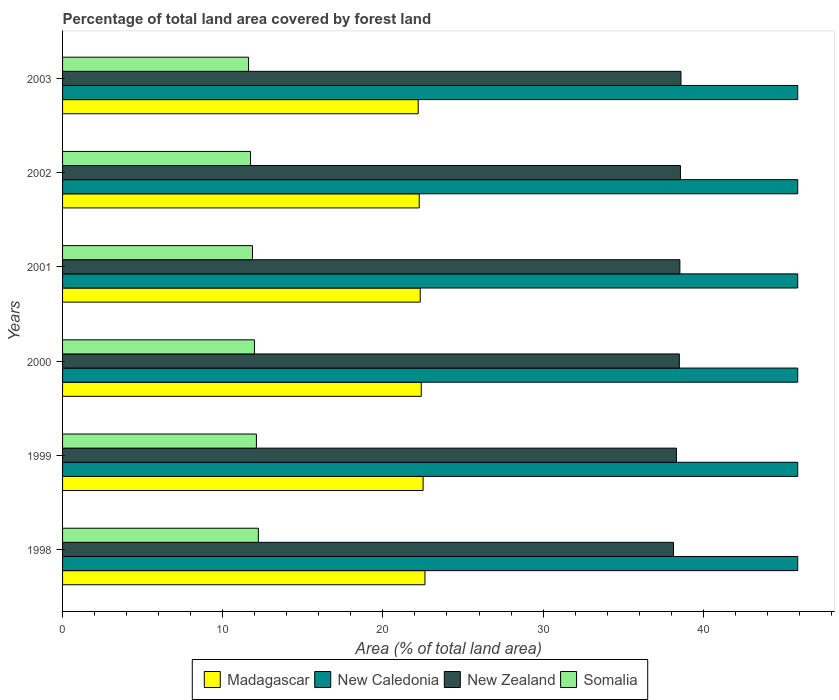How many different coloured bars are there?
Provide a succinct answer. 4. How many groups of bars are there?
Your response must be concise. 6. Are the number of bars on each tick of the Y-axis equal?
Ensure brevity in your answer.  Yes. How many bars are there on the 5th tick from the bottom?
Keep it short and to the point. 4. What is the label of the 5th group of bars from the top?
Provide a succinct answer. 1999. What is the percentage of forest land in Madagascar in 2003?
Keep it short and to the point. 22.2. Across all years, what is the maximum percentage of forest land in New Zealand?
Offer a very short reply. 38.61. Across all years, what is the minimum percentage of forest land in New Caledonia?
Offer a very short reply. 45.9. In which year was the percentage of forest land in Madagascar minimum?
Give a very brief answer. 2003. What is the total percentage of forest land in New Zealand in the graph?
Your answer should be very brief. 230.69. What is the difference between the percentage of forest land in Somalia in 2000 and that in 2001?
Your response must be concise. 0.12. What is the difference between the percentage of forest land in New Caledonia in 2000 and the percentage of forest land in Somalia in 2002?
Give a very brief answer. 34.16. What is the average percentage of forest land in Madagascar per year?
Your answer should be compact. 22.39. In the year 2001, what is the difference between the percentage of forest land in New Zealand and percentage of forest land in Madagascar?
Your response must be concise. 16.21. In how many years, is the percentage of forest land in Madagascar greater than 40 %?
Offer a terse response. 0. What is the ratio of the percentage of forest land in New Zealand in 1999 to that in 2000?
Your response must be concise. 1. What is the difference between the highest and the second highest percentage of forest land in New Zealand?
Offer a terse response. 0.03. What is the difference between the highest and the lowest percentage of forest land in New Zealand?
Provide a succinct answer. 0.47. Is it the case that in every year, the sum of the percentage of forest land in Madagascar and percentage of forest land in New Caledonia is greater than the sum of percentage of forest land in New Zealand and percentage of forest land in Somalia?
Ensure brevity in your answer.  Yes. What does the 3rd bar from the top in 2003 represents?
Ensure brevity in your answer.  New Caledonia. What does the 4th bar from the bottom in 1999 represents?
Offer a terse response. Somalia. How many years are there in the graph?
Make the answer very short. 6. Are the values on the major ticks of X-axis written in scientific E-notation?
Offer a very short reply. No. Does the graph contain any zero values?
Ensure brevity in your answer.  No. Where does the legend appear in the graph?
Ensure brevity in your answer.  Bottom center. How are the legend labels stacked?
Your answer should be very brief. Horizontal. What is the title of the graph?
Provide a succinct answer. Percentage of total land area covered by forest land. Does "Ethiopia" appear as one of the legend labels in the graph?
Provide a succinct answer. No. What is the label or title of the X-axis?
Your answer should be compact. Area (% of total land area). What is the label or title of the Y-axis?
Give a very brief answer. Years. What is the Area (% of total land area) in Madagascar in 1998?
Your response must be concise. 22.62. What is the Area (% of total land area) of New Caledonia in 1998?
Provide a succinct answer. 45.9. What is the Area (% of total land area) of New Zealand in 1998?
Make the answer very short. 38.14. What is the Area (% of total land area) of Somalia in 1998?
Provide a succinct answer. 12.22. What is the Area (% of total land area) of Madagascar in 1999?
Offer a very short reply. 22.51. What is the Area (% of total land area) of New Caledonia in 1999?
Make the answer very short. 45.9. What is the Area (% of total land area) of New Zealand in 1999?
Offer a very short reply. 38.32. What is the Area (% of total land area) of Somalia in 1999?
Offer a very short reply. 12.1. What is the Area (% of total land area) of Madagascar in 2000?
Provide a short and direct response. 22.39. What is the Area (% of total land area) in New Caledonia in 2000?
Give a very brief answer. 45.9. What is the Area (% of total land area) of New Zealand in 2000?
Your answer should be compact. 38.51. What is the Area (% of total land area) of Somalia in 2000?
Provide a short and direct response. 11.98. What is the Area (% of total land area) in Madagascar in 2001?
Provide a succinct answer. 22.33. What is the Area (% of total land area) in New Caledonia in 2001?
Keep it short and to the point. 45.9. What is the Area (% of total land area) of New Zealand in 2001?
Make the answer very short. 38.54. What is the Area (% of total land area) in Somalia in 2001?
Your answer should be compact. 11.86. What is the Area (% of total land area) in Madagascar in 2002?
Ensure brevity in your answer.  22.27. What is the Area (% of total land area) in New Caledonia in 2002?
Offer a terse response. 45.9. What is the Area (% of total land area) of New Zealand in 2002?
Your answer should be compact. 38.57. What is the Area (% of total land area) of Somalia in 2002?
Make the answer very short. 11.73. What is the Area (% of total land area) of Madagascar in 2003?
Your answer should be very brief. 22.2. What is the Area (% of total land area) in New Caledonia in 2003?
Keep it short and to the point. 45.9. What is the Area (% of total land area) of New Zealand in 2003?
Your response must be concise. 38.61. What is the Area (% of total land area) of Somalia in 2003?
Keep it short and to the point. 11.61. Across all years, what is the maximum Area (% of total land area) in Madagascar?
Provide a succinct answer. 22.62. Across all years, what is the maximum Area (% of total land area) in New Caledonia?
Your answer should be very brief. 45.9. Across all years, what is the maximum Area (% of total land area) of New Zealand?
Your answer should be compact. 38.61. Across all years, what is the maximum Area (% of total land area) in Somalia?
Give a very brief answer. 12.22. Across all years, what is the minimum Area (% of total land area) of Madagascar?
Offer a terse response. 22.2. Across all years, what is the minimum Area (% of total land area) of New Caledonia?
Provide a succinct answer. 45.9. Across all years, what is the minimum Area (% of total land area) of New Zealand?
Give a very brief answer. 38.14. Across all years, what is the minimum Area (% of total land area) in Somalia?
Your answer should be compact. 11.61. What is the total Area (% of total land area) in Madagascar in the graph?
Ensure brevity in your answer.  134.33. What is the total Area (% of total land area) of New Caledonia in the graph?
Provide a succinct answer. 275.38. What is the total Area (% of total land area) of New Zealand in the graph?
Make the answer very short. 230.69. What is the total Area (% of total land area) of Somalia in the graph?
Make the answer very short. 71.51. What is the difference between the Area (% of total land area) of Madagascar in 1998 and that in 1999?
Give a very brief answer. 0.12. What is the difference between the Area (% of total land area) of New Zealand in 1998 and that in 1999?
Provide a short and direct response. -0.18. What is the difference between the Area (% of total land area) of Somalia in 1998 and that in 1999?
Ensure brevity in your answer.  0.12. What is the difference between the Area (% of total land area) of Madagascar in 1998 and that in 2000?
Your answer should be compact. 0.23. What is the difference between the Area (% of total land area) in New Zealand in 1998 and that in 2000?
Provide a short and direct response. -0.37. What is the difference between the Area (% of total land area) in Somalia in 1998 and that in 2000?
Make the answer very short. 0.24. What is the difference between the Area (% of total land area) of Madagascar in 1998 and that in 2001?
Provide a succinct answer. 0.29. What is the difference between the Area (% of total land area) in New Zealand in 1998 and that in 2001?
Your answer should be compact. -0.4. What is the difference between the Area (% of total land area) of Somalia in 1998 and that in 2001?
Offer a very short reply. 0.37. What is the difference between the Area (% of total land area) in Madagascar in 1998 and that in 2002?
Offer a very short reply. 0.36. What is the difference between the Area (% of total land area) in New Zealand in 1998 and that in 2002?
Provide a succinct answer. -0.43. What is the difference between the Area (% of total land area) of Somalia in 1998 and that in 2002?
Offer a very short reply. 0.49. What is the difference between the Area (% of total land area) in Madagascar in 1998 and that in 2003?
Your answer should be compact. 0.42. What is the difference between the Area (% of total land area) of New Zealand in 1998 and that in 2003?
Keep it short and to the point. -0.47. What is the difference between the Area (% of total land area) in Somalia in 1998 and that in 2003?
Provide a succinct answer. 0.61. What is the difference between the Area (% of total land area) in Madagascar in 1999 and that in 2000?
Provide a succinct answer. 0.12. What is the difference between the Area (% of total land area) in New Caledonia in 1999 and that in 2000?
Provide a short and direct response. 0. What is the difference between the Area (% of total land area) of New Zealand in 1999 and that in 2000?
Offer a terse response. -0.18. What is the difference between the Area (% of total land area) of Somalia in 1999 and that in 2000?
Keep it short and to the point. 0.12. What is the difference between the Area (% of total land area) of Madagascar in 1999 and that in 2001?
Ensure brevity in your answer.  0.18. What is the difference between the Area (% of total land area) of New Caledonia in 1999 and that in 2001?
Keep it short and to the point. 0. What is the difference between the Area (% of total land area) in New Zealand in 1999 and that in 2001?
Keep it short and to the point. -0.22. What is the difference between the Area (% of total land area) in Somalia in 1999 and that in 2001?
Give a very brief answer. 0.24. What is the difference between the Area (% of total land area) in Madagascar in 1999 and that in 2002?
Offer a very short reply. 0.24. What is the difference between the Area (% of total land area) in New Caledonia in 1999 and that in 2002?
Offer a very short reply. 0. What is the difference between the Area (% of total land area) in New Zealand in 1999 and that in 2002?
Offer a very short reply. -0.25. What is the difference between the Area (% of total land area) in Somalia in 1999 and that in 2002?
Provide a short and direct response. 0.37. What is the difference between the Area (% of total land area) in Madagascar in 1999 and that in 2003?
Your response must be concise. 0.31. What is the difference between the Area (% of total land area) of New Caledonia in 1999 and that in 2003?
Provide a succinct answer. 0. What is the difference between the Area (% of total land area) of New Zealand in 1999 and that in 2003?
Offer a very short reply. -0.28. What is the difference between the Area (% of total land area) of Somalia in 1999 and that in 2003?
Your answer should be very brief. 0.49. What is the difference between the Area (% of total land area) of Madagascar in 2000 and that in 2001?
Offer a very short reply. 0.06. What is the difference between the Area (% of total land area) of New Caledonia in 2000 and that in 2001?
Provide a short and direct response. 0. What is the difference between the Area (% of total land area) in New Zealand in 2000 and that in 2001?
Provide a succinct answer. -0.03. What is the difference between the Area (% of total land area) of Somalia in 2000 and that in 2001?
Ensure brevity in your answer.  0.12. What is the difference between the Area (% of total land area) of Madagascar in 2000 and that in 2002?
Your answer should be compact. 0.13. What is the difference between the Area (% of total land area) in New Caledonia in 2000 and that in 2002?
Provide a short and direct response. 0. What is the difference between the Area (% of total land area) in New Zealand in 2000 and that in 2002?
Your answer should be compact. -0.07. What is the difference between the Area (% of total land area) of Somalia in 2000 and that in 2002?
Ensure brevity in your answer.  0.24. What is the difference between the Area (% of total land area) in Madagascar in 2000 and that in 2003?
Your answer should be very brief. 0.19. What is the difference between the Area (% of total land area) in New Caledonia in 2000 and that in 2003?
Your answer should be very brief. 0. What is the difference between the Area (% of total land area) in New Zealand in 2000 and that in 2003?
Ensure brevity in your answer.  -0.1. What is the difference between the Area (% of total land area) of Somalia in 2000 and that in 2003?
Your answer should be very brief. 0.37. What is the difference between the Area (% of total land area) of Madagascar in 2001 and that in 2002?
Keep it short and to the point. 0.06. What is the difference between the Area (% of total land area) in New Zealand in 2001 and that in 2002?
Your answer should be compact. -0.03. What is the difference between the Area (% of total land area) in Somalia in 2001 and that in 2002?
Provide a short and direct response. 0.12. What is the difference between the Area (% of total land area) of Madagascar in 2001 and that in 2003?
Provide a succinct answer. 0.13. What is the difference between the Area (% of total land area) in New Zealand in 2001 and that in 2003?
Provide a succinct answer. -0.07. What is the difference between the Area (% of total land area) in Somalia in 2001 and that in 2003?
Your answer should be very brief. 0.24. What is the difference between the Area (% of total land area) in Madagascar in 2002 and that in 2003?
Your response must be concise. 0.06. What is the difference between the Area (% of total land area) of New Zealand in 2002 and that in 2003?
Make the answer very short. -0.03. What is the difference between the Area (% of total land area) of Somalia in 2002 and that in 2003?
Your answer should be very brief. 0.12. What is the difference between the Area (% of total land area) of Madagascar in 1998 and the Area (% of total land area) of New Caledonia in 1999?
Offer a very short reply. -23.27. What is the difference between the Area (% of total land area) in Madagascar in 1998 and the Area (% of total land area) in New Zealand in 1999?
Offer a very short reply. -15.7. What is the difference between the Area (% of total land area) of Madagascar in 1998 and the Area (% of total land area) of Somalia in 1999?
Provide a succinct answer. 10.52. What is the difference between the Area (% of total land area) in New Caledonia in 1998 and the Area (% of total land area) in New Zealand in 1999?
Your response must be concise. 7.57. What is the difference between the Area (% of total land area) in New Caledonia in 1998 and the Area (% of total land area) in Somalia in 1999?
Your response must be concise. 33.8. What is the difference between the Area (% of total land area) of New Zealand in 1998 and the Area (% of total land area) of Somalia in 1999?
Provide a short and direct response. 26.04. What is the difference between the Area (% of total land area) of Madagascar in 1998 and the Area (% of total land area) of New Caledonia in 2000?
Offer a terse response. -23.27. What is the difference between the Area (% of total land area) of Madagascar in 1998 and the Area (% of total land area) of New Zealand in 2000?
Offer a terse response. -15.88. What is the difference between the Area (% of total land area) of Madagascar in 1998 and the Area (% of total land area) of Somalia in 2000?
Offer a terse response. 10.64. What is the difference between the Area (% of total land area) of New Caledonia in 1998 and the Area (% of total land area) of New Zealand in 2000?
Your answer should be compact. 7.39. What is the difference between the Area (% of total land area) in New Caledonia in 1998 and the Area (% of total land area) in Somalia in 2000?
Your response must be concise. 33.92. What is the difference between the Area (% of total land area) in New Zealand in 1998 and the Area (% of total land area) in Somalia in 2000?
Provide a short and direct response. 26.16. What is the difference between the Area (% of total land area) of Madagascar in 1998 and the Area (% of total land area) of New Caledonia in 2001?
Offer a terse response. -23.27. What is the difference between the Area (% of total land area) of Madagascar in 1998 and the Area (% of total land area) of New Zealand in 2001?
Your response must be concise. -15.92. What is the difference between the Area (% of total land area) of Madagascar in 1998 and the Area (% of total land area) of Somalia in 2001?
Ensure brevity in your answer.  10.77. What is the difference between the Area (% of total land area) of New Caledonia in 1998 and the Area (% of total land area) of New Zealand in 2001?
Your answer should be compact. 7.36. What is the difference between the Area (% of total land area) of New Caledonia in 1998 and the Area (% of total land area) of Somalia in 2001?
Ensure brevity in your answer.  34.04. What is the difference between the Area (% of total land area) of New Zealand in 1998 and the Area (% of total land area) of Somalia in 2001?
Your answer should be compact. 26.28. What is the difference between the Area (% of total land area) in Madagascar in 1998 and the Area (% of total land area) in New Caledonia in 2002?
Your response must be concise. -23.27. What is the difference between the Area (% of total land area) in Madagascar in 1998 and the Area (% of total land area) in New Zealand in 2002?
Keep it short and to the point. -15.95. What is the difference between the Area (% of total land area) of Madagascar in 1998 and the Area (% of total land area) of Somalia in 2002?
Provide a short and direct response. 10.89. What is the difference between the Area (% of total land area) of New Caledonia in 1998 and the Area (% of total land area) of New Zealand in 2002?
Ensure brevity in your answer.  7.32. What is the difference between the Area (% of total land area) of New Caledonia in 1998 and the Area (% of total land area) of Somalia in 2002?
Keep it short and to the point. 34.16. What is the difference between the Area (% of total land area) in New Zealand in 1998 and the Area (% of total land area) in Somalia in 2002?
Ensure brevity in your answer.  26.41. What is the difference between the Area (% of total land area) in Madagascar in 1998 and the Area (% of total land area) in New Caledonia in 2003?
Provide a short and direct response. -23.27. What is the difference between the Area (% of total land area) of Madagascar in 1998 and the Area (% of total land area) of New Zealand in 2003?
Your answer should be compact. -15.98. What is the difference between the Area (% of total land area) in Madagascar in 1998 and the Area (% of total land area) in Somalia in 2003?
Your answer should be compact. 11.01. What is the difference between the Area (% of total land area) of New Caledonia in 1998 and the Area (% of total land area) of New Zealand in 2003?
Your answer should be very brief. 7.29. What is the difference between the Area (% of total land area) of New Caledonia in 1998 and the Area (% of total land area) of Somalia in 2003?
Give a very brief answer. 34.29. What is the difference between the Area (% of total land area) in New Zealand in 1998 and the Area (% of total land area) in Somalia in 2003?
Your answer should be very brief. 26.53. What is the difference between the Area (% of total land area) of Madagascar in 1999 and the Area (% of total land area) of New Caledonia in 2000?
Your response must be concise. -23.39. What is the difference between the Area (% of total land area) of Madagascar in 1999 and the Area (% of total land area) of New Zealand in 2000?
Make the answer very short. -16. What is the difference between the Area (% of total land area) of Madagascar in 1999 and the Area (% of total land area) of Somalia in 2000?
Give a very brief answer. 10.53. What is the difference between the Area (% of total land area) of New Caledonia in 1999 and the Area (% of total land area) of New Zealand in 2000?
Give a very brief answer. 7.39. What is the difference between the Area (% of total land area) in New Caledonia in 1999 and the Area (% of total land area) in Somalia in 2000?
Provide a short and direct response. 33.92. What is the difference between the Area (% of total land area) of New Zealand in 1999 and the Area (% of total land area) of Somalia in 2000?
Keep it short and to the point. 26.34. What is the difference between the Area (% of total land area) of Madagascar in 1999 and the Area (% of total land area) of New Caledonia in 2001?
Ensure brevity in your answer.  -23.39. What is the difference between the Area (% of total land area) of Madagascar in 1999 and the Area (% of total land area) of New Zealand in 2001?
Keep it short and to the point. -16.03. What is the difference between the Area (% of total land area) of Madagascar in 1999 and the Area (% of total land area) of Somalia in 2001?
Your response must be concise. 10.65. What is the difference between the Area (% of total land area) in New Caledonia in 1999 and the Area (% of total land area) in New Zealand in 2001?
Offer a very short reply. 7.36. What is the difference between the Area (% of total land area) of New Caledonia in 1999 and the Area (% of total land area) of Somalia in 2001?
Provide a succinct answer. 34.04. What is the difference between the Area (% of total land area) of New Zealand in 1999 and the Area (% of total land area) of Somalia in 2001?
Provide a short and direct response. 26.47. What is the difference between the Area (% of total land area) in Madagascar in 1999 and the Area (% of total land area) in New Caledonia in 2002?
Keep it short and to the point. -23.39. What is the difference between the Area (% of total land area) of Madagascar in 1999 and the Area (% of total land area) of New Zealand in 2002?
Your response must be concise. -16.06. What is the difference between the Area (% of total land area) of Madagascar in 1999 and the Area (% of total land area) of Somalia in 2002?
Provide a succinct answer. 10.77. What is the difference between the Area (% of total land area) in New Caledonia in 1999 and the Area (% of total land area) in New Zealand in 2002?
Your answer should be very brief. 7.32. What is the difference between the Area (% of total land area) in New Caledonia in 1999 and the Area (% of total land area) in Somalia in 2002?
Offer a very short reply. 34.16. What is the difference between the Area (% of total land area) in New Zealand in 1999 and the Area (% of total land area) in Somalia in 2002?
Offer a very short reply. 26.59. What is the difference between the Area (% of total land area) of Madagascar in 1999 and the Area (% of total land area) of New Caledonia in 2003?
Offer a terse response. -23.39. What is the difference between the Area (% of total land area) in Madagascar in 1999 and the Area (% of total land area) in New Zealand in 2003?
Provide a succinct answer. -16.1. What is the difference between the Area (% of total land area) in Madagascar in 1999 and the Area (% of total land area) in Somalia in 2003?
Keep it short and to the point. 10.9. What is the difference between the Area (% of total land area) of New Caledonia in 1999 and the Area (% of total land area) of New Zealand in 2003?
Give a very brief answer. 7.29. What is the difference between the Area (% of total land area) in New Caledonia in 1999 and the Area (% of total land area) in Somalia in 2003?
Offer a terse response. 34.29. What is the difference between the Area (% of total land area) of New Zealand in 1999 and the Area (% of total land area) of Somalia in 2003?
Your answer should be compact. 26.71. What is the difference between the Area (% of total land area) of Madagascar in 2000 and the Area (% of total land area) of New Caledonia in 2001?
Make the answer very short. -23.5. What is the difference between the Area (% of total land area) in Madagascar in 2000 and the Area (% of total land area) in New Zealand in 2001?
Give a very brief answer. -16.15. What is the difference between the Area (% of total land area) of Madagascar in 2000 and the Area (% of total land area) of Somalia in 2001?
Give a very brief answer. 10.54. What is the difference between the Area (% of total land area) in New Caledonia in 2000 and the Area (% of total land area) in New Zealand in 2001?
Your response must be concise. 7.36. What is the difference between the Area (% of total land area) of New Caledonia in 2000 and the Area (% of total land area) of Somalia in 2001?
Provide a succinct answer. 34.04. What is the difference between the Area (% of total land area) in New Zealand in 2000 and the Area (% of total land area) in Somalia in 2001?
Your response must be concise. 26.65. What is the difference between the Area (% of total land area) of Madagascar in 2000 and the Area (% of total land area) of New Caledonia in 2002?
Your response must be concise. -23.5. What is the difference between the Area (% of total land area) in Madagascar in 2000 and the Area (% of total land area) in New Zealand in 2002?
Ensure brevity in your answer.  -16.18. What is the difference between the Area (% of total land area) of Madagascar in 2000 and the Area (% of total land area) of Somalia in 2002?
Offer a terse response. 10.66. What is the difference between the Area (% of total land area) in New Caledonia in 2000 and the Area (% of total land area) in New Zealand in 2002?
Ensure brevity in your answer.  7.32. What is the difference between the Area (% of total land area) in New Caledonia in 2000 and the Area (% of total land area) in Somalia in 2002?
Give a very brief answer. 34.16. What is the difference between the Area (% of total land area) in New Zealand in 2000 and the Area (% of total land area) in Somalia in 2002?
Provide a succinct answer. 26.77. What is the difference between the Area (% of total land area) of Madagascar in 2000 and the Area (% of total land area) of New Caledonia in 2003?
Give a very brief answer. -23.5. What is the difference between the Area (% of total land area) of Madagascar in 2000 and the Area (% of total land area) of New Zealand in 2003?
Your answer should be compact. -16.21. What is the difference between the Area (% of total land area) in Madagascar in 2000 and the Area (% of total land area) in Somalia in 2003?
Provide a succinct answer. 10.78. What is the difference between the Area (% of total land area) of New Caledonia in 2000 and the Area (% of total land area) of New Zealand in 2003?
Your response must be concise. 7.29. What is the difference between the Area (% of total land area) in New Caledonia in 2000 and the Area (% of total land area) in Somalia in 2003?
Ensure brevity in your answer.  34.29. What is the difference between the Area (% of total land area) in New Zealand in 2000 and the Area (% of total land area) in Somalia in 2003?
Offer a very short reply. 26.89. What is the difference between the Area (% of total land area) of Madagascar in 2001 and the Area (% of total land area) of New Caledonia in 2002?
Keep it short and to the point. -23.57. What is the difference between the Area (% of total land area) of Madagascar in 2001 and the Area (% of total land area) of New Zealand in 2002?
Keep it short and to the point. -16.24. What is the difference between the Area (% of total land area) in Madagascar in 2001 and the Area (% of total land area) in Somalia in 2002?
Your response must be concise. 10.6. What is the difference between the Area (% of total land area) in New Caledonia in 2001 and the Area (% of total land area) in New Zealand in 2002?
Offer a very short reply. 7.32. What is the difference between the Area (% of total land area) of New Caledonia in 2001 and the Area (% of total land area) of Somalia in 2002?
Give a very brief answer. 34.16. What is the difference between the Area (% of total land area) in New Zealand in 2001 and the Area (% of total land area) in Somalia in 2002?
Keep it short and to the point. 26.81. What is the difference between the Area (% of total land area) in Madagascar in 2001 and the Area (% of total land area) in New Caledonia in 2003?
Ensure brevity in your answer.  -23.57. What is the difference between the Area (% of total land area) of Madagascar in 2001 and the Area (% of total land area) of New Zealand in 2003?
Your response must be concise. -16.28. What is the difference between the Area (% of total land area) of Madagascar in 2001 and the Area (% of total land area) of Somalia in 2003?
Give a very brief answer. 10.72. What is the difference between the Area (% of total land area) in New Caledonia in 2001 and the Area (% of total land area) in New Zealand in 2003?
Offer a very short reply. 7.29. What is the difference between the Area (% of total land area) in New Caledonia in 2001 and the Area (% of total land area) in Somalia in 2003?
Ensure brevity in your answer.  34.29. What is the difference between the Area (% of total land area) of New Zealand in 2001 and the Area (% of total land area) of Somalia in 2003?
Give a very brief answer. 26.93. What is the difference between the Area (% of total land area) in Madagascar in 2002 and the Area (% of total land area) in New Caledonia in 2003?
Your answer should be very brief. -23.63. What is the difference between the Area (% of total land area) of Madagascar in 2002 and the Area (% of total land area) of New Zealand in 2003?
Make the answer very short. -16.34. What is the difference between the Area (% of total land area) in Madagascar in 2002 and the Area (% of total land area) in Somalia in 2003?
Offer a terse response. 10.65. What is the difference between the Area (% of total land area) in New Caledonia in 2002 and the Area (% of total land area) in New Zealand in 2003?
Offer a terse response. 7.29. What is the difference between the Area (% of total land area) in New Caledonia in 2002 and the Area (% of total land area) in Somalia in 2003?
Offer a very short reply. 34.29. What is the difference between the Area (% of total land area) of New Zealand in 2002 and the Area (% of total land area) of Somalia in 2003?
Offer a terse response. 26.96. What is the average Area (% of total land area) in Madagascar per year?
Provide a short and direct response. 22.39. What is the average Area (% of total land area) in New Caledonia per year?
Keep it short and to the point. 45.9. What is the average Area (% of total land area) of New Zealand per year?
Keep it short and to the point. 38.45. What is the average Area (% of total land area) in Somalia per year?
Ensure brevity in your answer.  11.92. In the year 1998, what is the difference between the Area (% of total land area) in Madagascar and Area (% of total land area) in New Caledonia?
Ensure brevity in your answer.  -23.27. In the year 1998, what is the difference between the Area (% of total land area) of Madagascar and Area (% of total land area) of New Zealand?
Keep it short and to the point. -15.52. In the year 1998, what is the difference between the Area (% of total land area) of Madagascar and Area (% of total land area) of Somalia?
Make the answer very short. 10.4. In the year 1998, what is the difference between the Area (% of total land area) in New Caledonia and Area (% of total land area) in New Zealand?
Provide a succinct answer. 7.76. In the year 1998, what is the difference between the Area (% of total land area) in New Caledonia and Area (% of total land area) in Somalia?
Give a very brief answer. 33.67. In the year 1998, what is the difference between the Area (% of total land area) of New Zealand and Area (% of total land area) of Somalia?
Keep it short and to the point. 25.92. In the year 1999, what is the difference between the Area (% of total land area) in Madagascar and Area (% of total land area) in New Caledonia?
Provide a succinct answer. -23.39. In the year 1999, what is the difference between the Area (% of total land area) in Madagascar and Area (% of total land area) in New Zealand?
Keep it short and to the point. -15.81. In the year 1999, what is the difference between the Area (% of total land area) in Madagascar and Area (% of total land area) in Somalia?
Give a very brief answer. 10.41. In the year 1999, what is the difference between the Area (% of total land area) of New Caledonia and Area (% of total land area) of New Zealand?
Provide a short and direct response. 7.57. In the year 1999, what is the difference between the Area (% of total land area) in New Caledonia and Area (% of total land area) in Somalia?
Ensure brevity in your answer.  33.8. In the year 1999, what is the difference between the Area (% of total land area) of New Zealand and Area (% of total land area) of Somalia?
Give a very brief answer. 26.22. In the year 2000, what is the difference between the Area (% of total land area) in Madagascar and Area (% of total land area) in New Caledonia?
Your answer should be compact. -23.5. In the year 2000, what is the difference between the Area (% of total land area) in Madagascar and Area (% of total land area) in New Zealand?
Make the answer very short. -16.11. In the year 2000, what is the difference between the Area (% of total land area) of Madagascar and Area (% of total land area) of Somalia?
Provide a succinct answer. 10.41. In the year 2000, what is the difference between the Area (% of total land area) in New Caledonia and Area (% of total land area) in New Zealand?
Give a very brief answer. 7.39. In the year 2000, what is the difference between the Area (% of total land area) of New Caledonia and Area (% of total land area) of Somalia?
Give a very brief answer. 33.92. In the year 2000, what is the difference between the Area (% of total land area) of New Zealand and Area (% of total land area) of Somalia?
Your answer should be compact. 26.53. In the year 2001, what is the difference between the Area (% of total land area) of Madagascar and Area (% of total land area) of New Caledonia?
Ensure brevity in your answer.  -23.57. In the year 2001, what is the difference between the Area (% of total land area) in Madagascar and Area (% of total land area) in New Zealand?
Give a very brief answer. -16.21. In the year 2001, what is the difference between the Area (% of total land area) in Madagascar and Area (% of total land area) in Somalia?
Keep it short and to the point. 10.47. In the year 2001, what is the difference between the Area (% of total land area) of New Caledonia and Area (% of total land area) of New Zealand?
Ensure brevity in your answer.  7.36. In the year 2001, what is the difference between the Area (% of total land area) of New Caledonia and Area (% of total land area) of Somalia?
Your response must be concise. 34.04. In the year 2001, what is the difference between the Area (% of total land area) of New Zealand and Area (% of total land area) of Somalia?
Give a very brief answer. 26.68. In the year 2002, what is the difference between the Area (% of total land area) of Madagascar and Area (% of total land area) of New Caledonia?
Offer a terse response. -23.63. In the year 2002, what is the difference between the Area (% of total land area) of Madagascar and Area (% of total land area) of New Zealand?
Your answer should be very brief. -16.31. In the year 2002, what is the difference between the Area (% of total land area) in Madagascar and Area (% of total land area) in Somalia?
Offer a very short reply. 10.53. In the year 2002, what is the difference between the Area (% of total land area) of New Caledonia and Area (% of total land area) of New Zealand?
Provide a short and direct response. 7.32. In the year 2002, what is the difference between the Area (% of total land area) in New Caledonia and Area (% of total land area) in Somalia?
Your answer should be very brief. 34.16. In the year 2002, what is the difference between the Area (% of total land area) in New Zealand and Area (% of total land area) in Somalia?
Make the answer very short. 26.84. In the year 2003, what is the difference between the Area (% of total land area) of Madagascar and Area (% of total land area) of New Caledonia?
Your answer should be compact. -23.69. In the year 2003, what is the difference between the Area (% of total land area) of Madagascar and Area (% of total land area) of New Zealand?
Make the answer very short. -16.4. In the year 2003, what is the difference between the Area (% of total land area) of Madagascar and Area (% of total land area) of Somalia?
Your answer should be compact. 10.59. In the year 2003, what is the difference between the Area (% of total land area) in New Caledonia and Area (% of total land area) in New Zealand?
Your answer should be compact. 7.29. In the year 2003, what is the difference between the Area (% of total land area) in New Caledonia and Area (% of total land area) in Somalia?
Your answer should be compact. 34.29. In the year 2003, what is the difference between the Area (% of total land area) of New Zealand and Area (% of total land area) of Somalia?
Your answer should be compact. 26.99. What is the ratio of the Area (% of total land area) of New Zealand in 1998 to that in 1999?
Provide a succinct answer. 1. What is the ratio of the Area (% of total land area) of Somalia in 1998 to that in 1999?
Provide a short and direct response. 1.01. What is the ratio of the Area (% of total land area) in Madagascar in 1998 to that in 2000?
Provide a short and direct response. 1.01. What is the ratio of the Area (% of total land area) of New Caledonia in 1998 to that in 2000?
Your answer should be very brief. 1. What is the ratio of the Area (% of total land area) in Somalia in 1998 to that in 2000?
Keep it short and to the point. 1.02. What is the ratio of the Area (% of total land area) in Madagascar in 1998 to that in 2001?
Your response must be concise. 1.01. What is the ratio of the Area (% of total land area) in New Zealand in 1998 to that in 2001?
Your response must be concise. 0.99. What is the ratio of the Area (% of total land area) of Somalia in 1998 to that in 2001?
Keep it short and to the point. 1.03. What is the ratio of the Area (% of total land area) in New Caledonia in 1998 to that in 2002?
Offer a terse response. 1. What is the ratio of the Area (% of total land area) of Somalia in 1998 to that in 2002?
Offer a terse response. 1.04. What is the ratio of the Area (% of total land area) in New Caledonia in 1998 to that in 2003?
Ensure brevity in your answer.  1. What is the ratio of the Area (% of total land area) of New Zealand in 1998 to that in 2003?
Your answer should be compact. 0.99. What is the ratio of the Area (% of total land area) in Somalia in 1998 to that in 2003?
Provide a short and direct response. 1.05. What is the ratio of the Area (% of total land area) in Madagascar in 1999 to that in 2000?
Make the answer very short. 1.01. What is the ratio of the Area (% of total land area) in Somalia in 1999 to that in 2000?
Offer a terse response. 1.01. What is the ratio of the Area (% of total land area) of Madagascar in 1999 to that in 2001?
Keep it short and to the point. 1.01. What is the ratio of the Area (% of total land area) of New Caledonia in 1999 to that in 2001?
Make the answer very short. 1. What is the ratio of the Area (% of total land area) in Somalia in 1999 to that in 2001?
Offer a terse response. 1.02. What is the ratio of the Area (% of total land area) in Madagascar in 1999 to that in 2002?
Keep it short and to the point. 1.01. What is the ratio of the Area (% of total land area) in New Caledonia in 1999 to that in 2002?
Your answer should be compact. 1. What is the ratio of the Area (% of total land area) in Somalia in 1999 to that in 2002?
Ensure brevity in your answer.  1.03. What is the ratio of the Area (% of total land area) of Madagascar in 1999 to that in 2003?
Offer a very short reply. 1.01. What is the ratio of the Area (% of total land area) in Somalia in 1999 to that in 2003?
Your answer should be compact. 1.04. What is the ratio of the Area (% of total land area) of Madagascar in 2000 to that in 2001?
Keep it short and to the point. 1. What is the ratio of the Area (% of total land area) of Somalia in 2000 to that in 2001?
Give a very brief answer. 1.01. What is the ratio of the Area (% of total land area) of New Caledonia in 2000 to that in 2002?
Ensure brevity in your answer.  1. What is the ratio of the Area (% of total land area) in New Zealand in 2000 to that in 2002?
Provide a succinct answer. 1. What is the ratio of the Area (% of total land area) in Somalia in 2000 to that in 2002?
Keep it short and to the point. 1.02. What is the ratio of the Area (% of total land area) of Madagascar in 2000 to that in 2003?
Give a very brief answer. 1.01. What is the ratio of the Area (% of total land area) of New Caledonia in 2000 to that in 2003?
Give a very brief answer. 1. What is the ratio of the Area (% of total land area) of New Zealand in 2000 to that in 2003?
Give a very brief answer. 1. What is the ratio of the Area (% of total land area) of Somalia in 2000 to that in 2003?
Give a very brief answer. 1.03. What is the ratio of the Area (% of total land area) of New Caledonia in 2001 to that in 2002?
Offer a terse response. 1. What is the ratio of the Area (% of total land area) in New Zealand in 2001 to that in 2002?
Your answer should be compact. 1. What is the ratio of the Area (% of total land area) of Somalia in 2001 to that in 2002?
Your answer should be compact. 1.01. What is the ratio of the Area (% of total land area) in Madagascar in 2001 to that in 2003?
Your answer should be compact. 1.01. What is the ratio of the Area (% of total land area) of New Zealand in 2001 to that in 2003?
Your answer should be very brief. 1. What is the ratio of the Area (% of total land area) of Somalia in 2001 to that in 2003?
Your answer should be compact. 1.02. What is the ratio of the Area (% of total land area) of New Caledonia in 2002 to that in 2003?
Provide a succinct answer. 1. What is the ratio of the Area (% of total land area) in New Zealand in 2002 to that in 2003?
Keep it short and to the point. 1. What is the ratio of the Area (% of total land area) in Somalia in 2002 to that in 2003?
Offer a terse response. 1.01. What is the difference between the highest and the second highest Area (% of total land area) in Madagascar?
Offer a very short reply. 0.12. What is the difference between the highest and the second highest Area (% of total land area) of New Caledonia?
Give a very brief answer. 0. What is the difference between the highest and the second highest Area (% of total land area) of New Zealand?
Offer a terse response. 0.03. What is the difference between the highest and the second highest Area (% of total land area) of Somalia?
Provide a succinct answer. 0.12. What is the difference between the highest and the lowest Area (% of total land area) in Madagascar?
Provide a short and direct response. 0.42. What is the difference between the highest and the lowest Area (% of total land area) of New Zealand?
Keep it short and to the point. 0.47. What is the difference between the highest and the lowest Area (% of total land area) in Somalia?
Give a very brief answer. 0.61. 